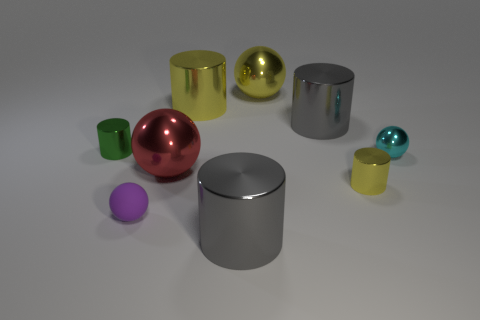What number of other objects are there of the same material as the small purple thing?
Offer a terse response. 0. What is the material of the sphere that is the same size as the red object?
Your answer should be very brief. Metal. What number of red objects are big metal things or small balls?
Provide a succinct answer. 1. The small thing that is in front of the red object and behind the purple rubber sphere is what color?
Keep it short and to the point. Yellow. Does the big gray cylinder that is behind the tiny yellow shiny thing have the same material as the tiny purple object on the right side of the small green object?
Offer a very short reply. No. Is the number of green shiny things in front of the tiny yellow metal thing greater than the number of big red objects that are right of the large red ball?
Provide a short and direct response. No. What is the shape of the cyan metal object that is the same size as the purple rubber thing?
Give a very brief answer. Sphere. What number of things are either big purple metal spheres or big gray things in front of the small yellow metallic object?
Your answer should be compact. 1. There is a small yellow metallic cylinder; what number of small yellow metallic cylinders are behind it?
Offer a very short reply. 0. What color is the other large ball that is the same material as the big red ball?
Your answer should be compact. Yellow. 